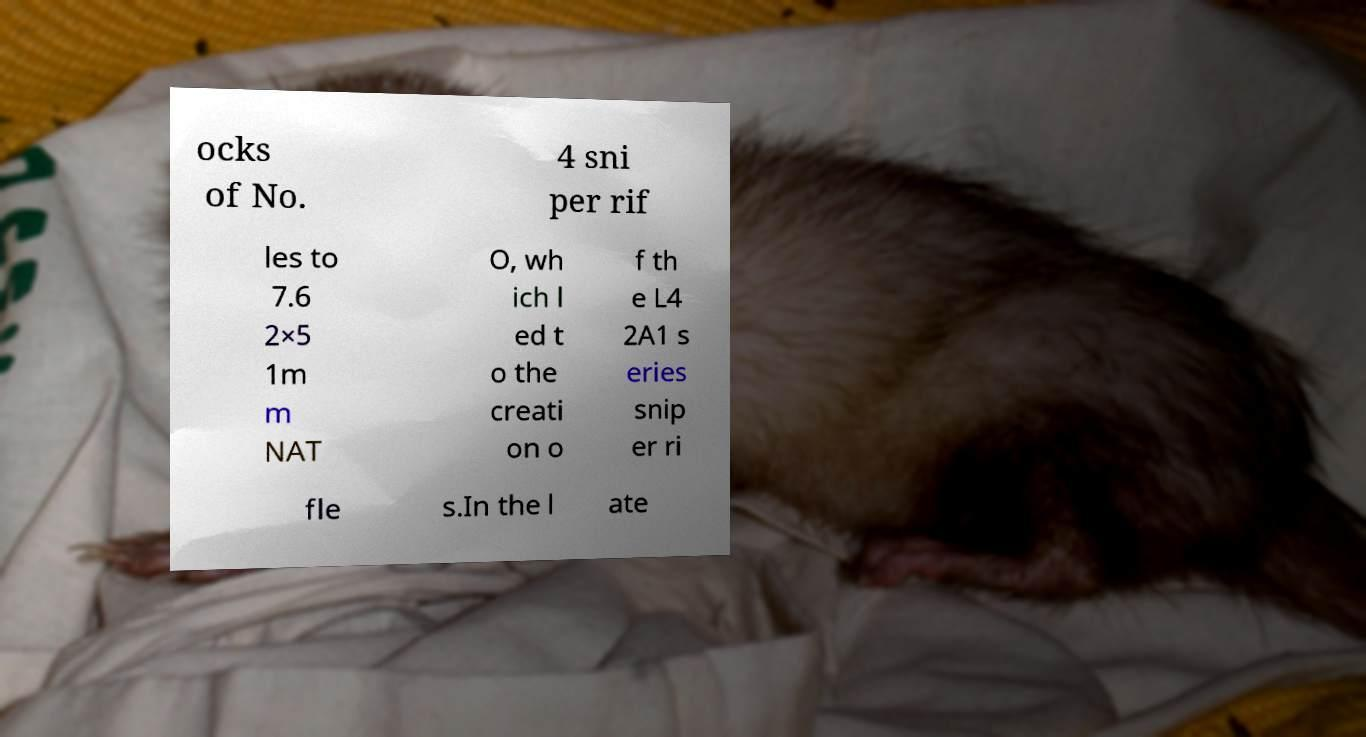What messages or text are displayed in this image? I need them in a readable, typed format. ocks of No. 4 sni per rif les to 7.6 2×5 1m m NAT O, wh ich l ed t o the creati on o f th e L4 2A1 s eries snip er ri fle s.In the l ate 